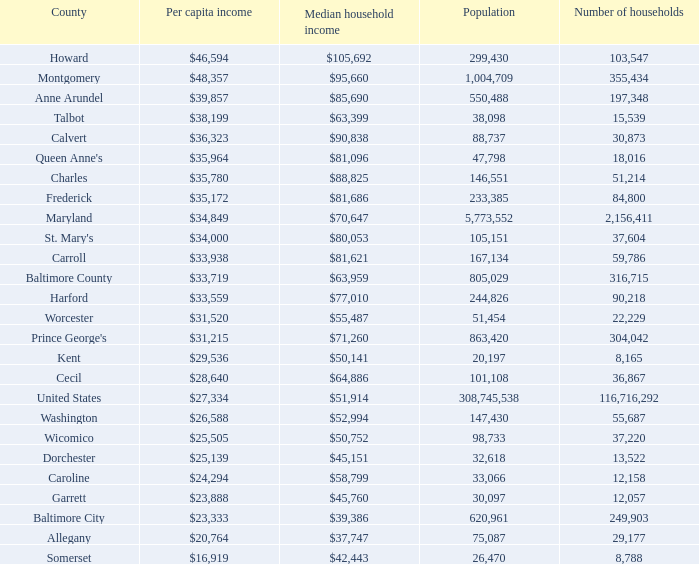What is the income per person for charles county? $35,780. 